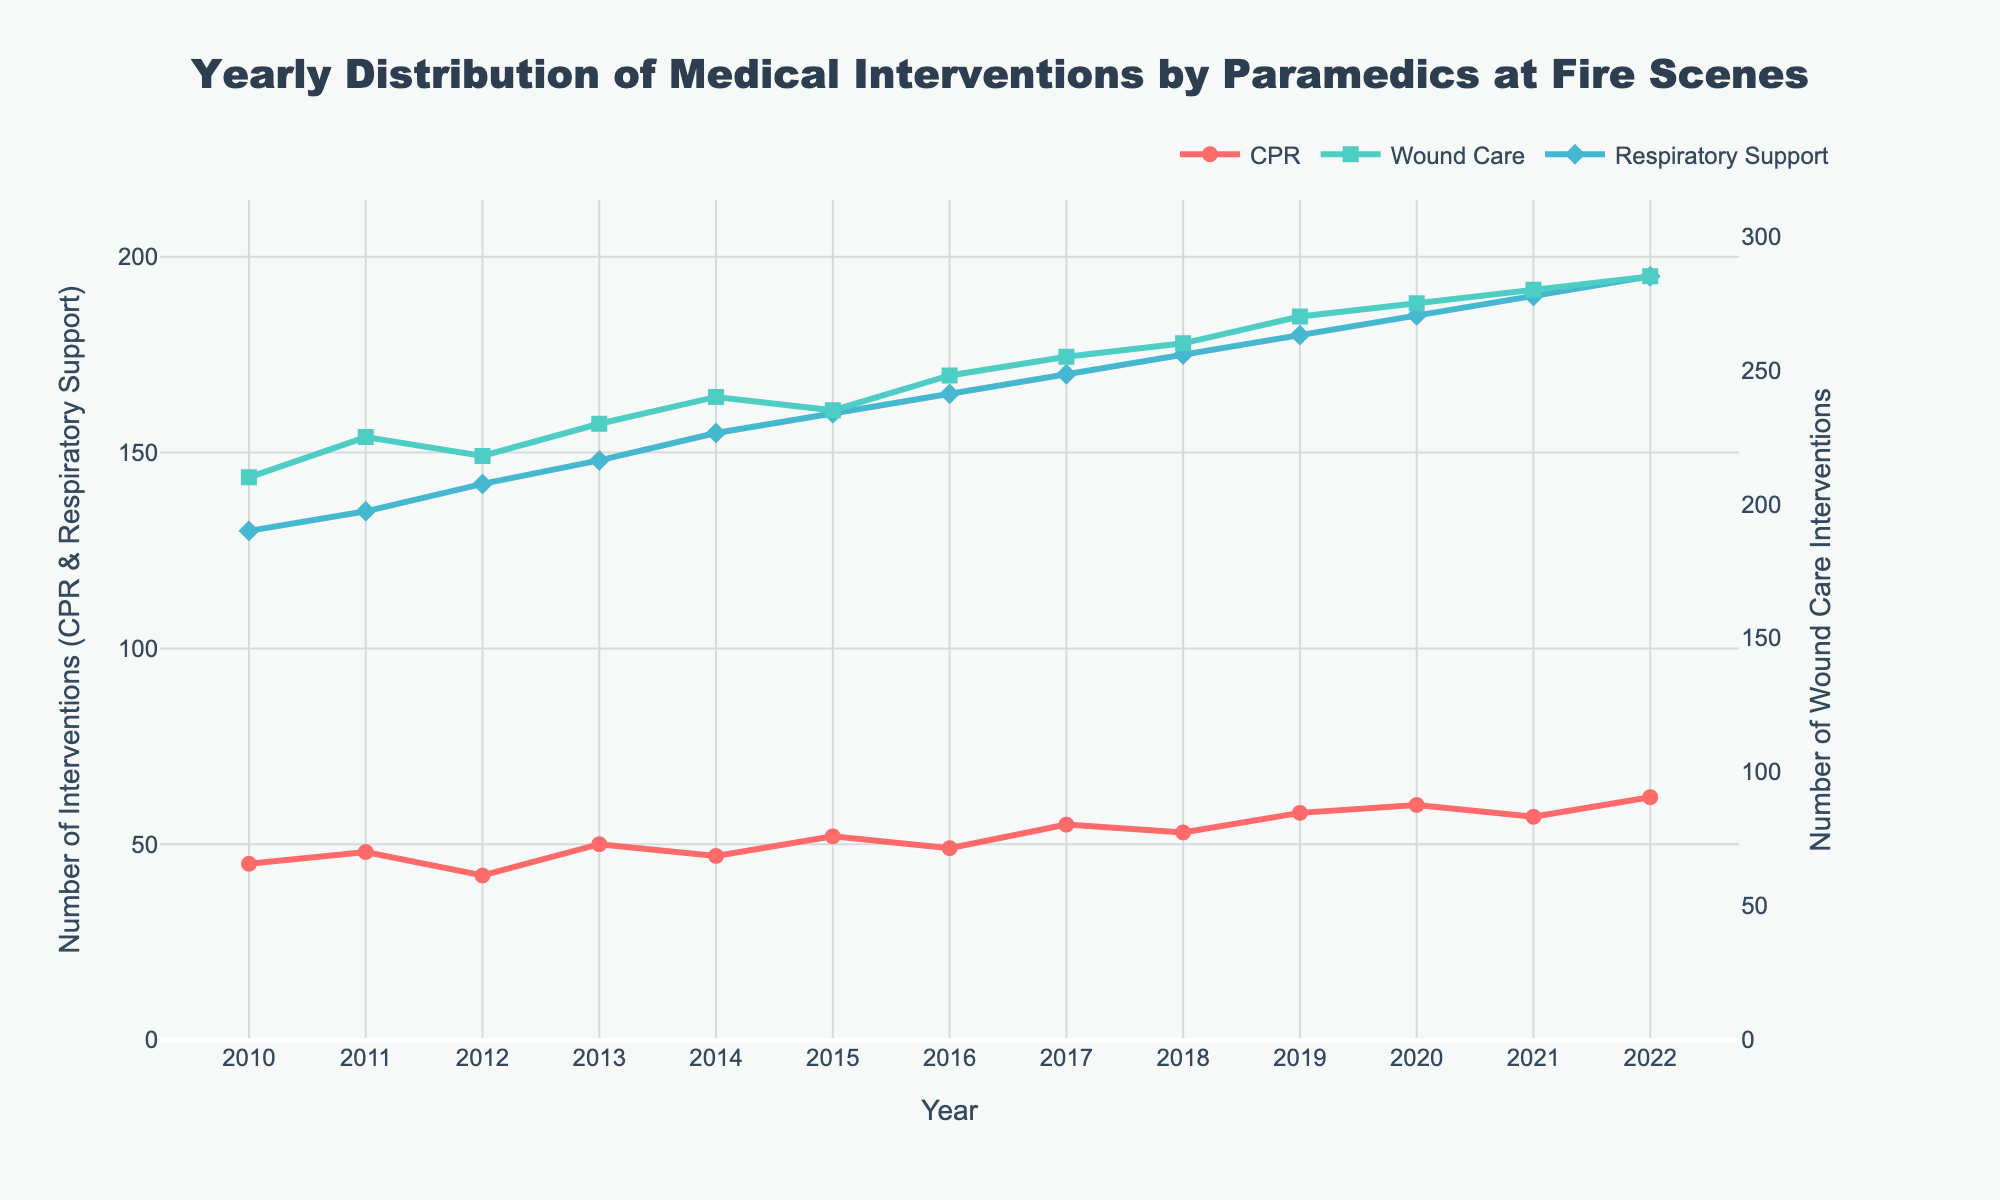What is the overall trend in the number of CPR interventions from 2010 to 2022? To determine the trend for CPR interventions, observe the values plotted for CPR on the line chart from 2010 to 2022. The data shows a general increasing trend with minor fluctuations, rising from 45 in 2010 to 62 in 2022.
Answer: Increasing How does the number of wound care interventions in 2013 compare to the number of respiratory support interventions in 2013? Locate the markers for the year 2013 for both wound care and respiratory support on the line chart. The line for wound care shows a value of 230, while the line for respiratory support shows a value of 148.
Answer: Wound care is higher What is the maximum number of interventions observed for any type in any year within the dataset? Identify the highest point in all three lines on the chart. The wound care line reaches up to 285 in 2022, which is the maximum number of interventions observed.
Answer: 285 Which year shows the highest increase in respiratory support interventions compared to the previous year? Calculate the year-over-year change for respiratory support interventions for each year by observing the slope of the line and the differences in values. The highest increase occurs from 2012 (142) to 2013 (148), which is an increase of 6 interventions.
Answer: 2013 How does the number of CPR interventions change between 2019 and 2020, and is it an increase or decrease? Compare the values of CPR for the years 2019 and 2020. For 2019, CPR interventions are 58, and for 2020, they are 60. The differences show a change of 2 interventions, indicating an increase.
Answer: Increase by 2 What are the average yearly interventions for wound care from 2010 to 2022? Sum the yearly interventions for wound care from 2010 (210) to 2022 (285) and divide by the number of years (13). Sum = 3271, and average = 3271 / 13 ≈ 251.62
Answer: Approximately 251.62 Between which two consecutive years does the CPR intervention rate show the smallest change? Examine the year-over-year changes for CPR interventions on the chart. The smallest change occurs between 2020 (60) and 2021 (57) with a decrease of 3 interventions.
Answer: Between 2020 and 2021 What was the total number of respiratory support interventions over the entire period from 2010 to 2022? Sum the yearly values of respiratory support interventions from 2010 (130) to 2022 (195). The total is 2060.
Answer: 2060 Between 2015 and 2020, which type of intervention saw the highest increase in terms of its total sum? Calculate the total interventions for CPR, wound care, and respiratory support separately from 2015 to 2020, then find the difference. CPR: 52+49+55+53+58+60 = 327, Wound Care: 235+248+255+260+270+275 = 1543, Respiratory Support: 160+165+170+175+180+185= 1035. The highest increase is in wound care, size difference: 1543 - 1275 = 268.
Answer: Wound Care 